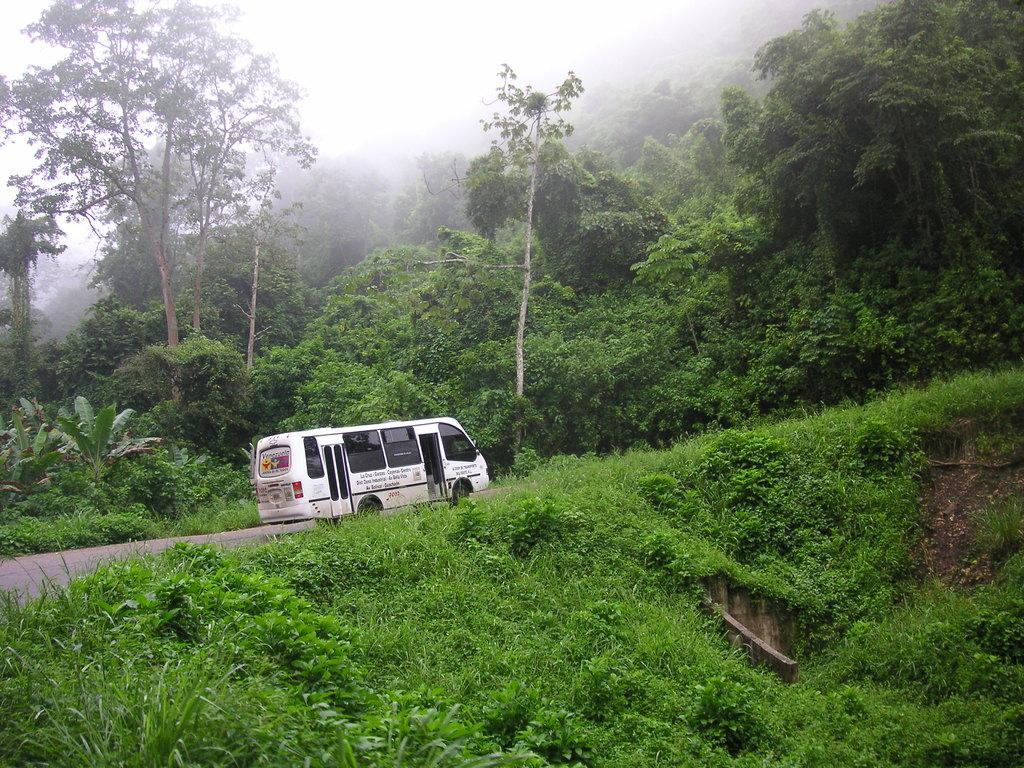What is the main subject in the center of the image? There is a vehicle in the center of the image. What type of vegetation is present at the bottom of the image? There is grass and plants at the bottom of the image. What kind of path can be seen in the image? There is a walkway in the image. What can be seen in the background of the image? There are trees, plants, and grass in the background of the image. What type of insect is flying over the vehicle in the image? There are no insects visible in the image. Can you see steam coming from the vehicle in the image? There is no steam visible in the image. 